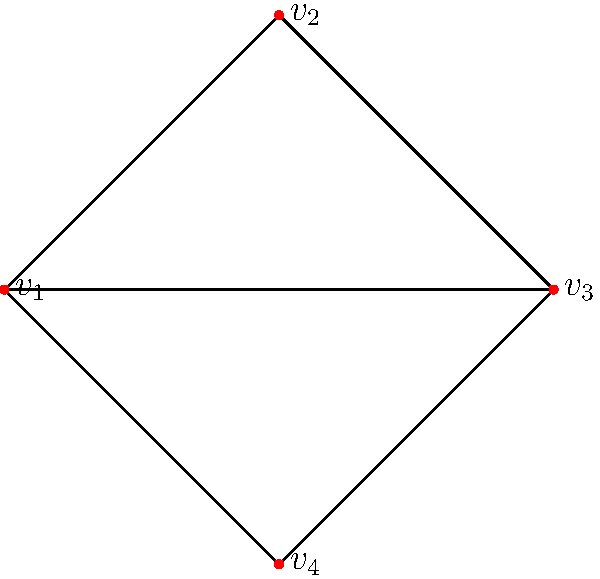In the context of applying knot theory to economic network structures, consider the graph shown above. If each node represents an economic agent and each edge represents a financial transaction, what is the crossing number of this graph, and how might this relate to the complexity of the economic system it represents? To answer this question, we need to follow these steps:

1. Understand the concept of crossing number:
   The crossing number of a graph is the minimum number of edge crossings when the graph is drawn in the plane.

2. Analyze the given graph:
   - The graph has 4 nodes (economic agents) labeled $v_1$, $v_2$, $v_3$, and $v_4$.
   - There are 5 edges (financial transactions) connecting these nodes.

3. Count the number of crossings:
   - In this particular representation, we can see that there is exactly one crossing between the edges $v_1v_3$ and $v_2v_4$.
   - This is the minimum number of crossings possible for this graph structure.

4. Determine the crossing number:
   The crossing number of this graph is 1.

5. Relate to economic complexity:
   - In the context of economic networks, a higher crossing number could indicate a more complex system of interactions between agents.
   - A crossing number of 1 suggests a relatively simple structure, but still with some non-trivial interactions.
   - This could represent an economic system where most transactions are straightforward, but there is at least one instance of more complex, intertwined relationships between agents.

6. Knot theory application:
   - In knot theory, crossings are fundamental in determining the complexity and classification of knots.
   - Similarly, in economic networks, the number and nature of "crossings" (complex interactions) can be indicative of the system's overall complexity and potential for intricate behaviors.
Answer: 1; indicates moderately low economic complexity 